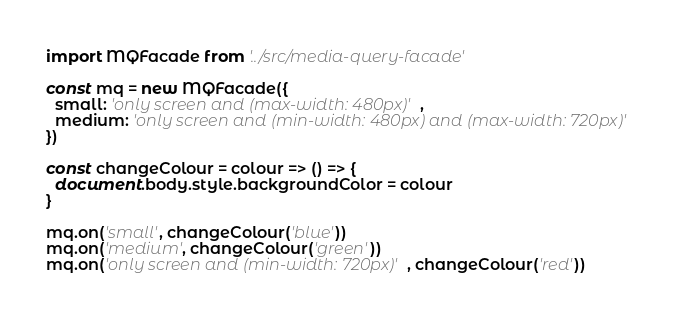Convert code to text. <code><loc_0><loc_0><loc_500><loc_500><_JavaScript_>import MQFacade from '../src/media-query-facade'

const mq = new MQFacade({
  small: 'only screen and (max-width: 480px)',
  medium: 'only screen and (min-width: 480px) and (max-width: 720px)'
})

const changeColour = colour => () => {
  document.body.style.backgroundColor = colour
}

mq.on('small', changeColour('blue'))
mq.on('medium', changeColour('green'))
mq.on('only screen and (min-width: 720px)', changeColour('red'))
</code> 